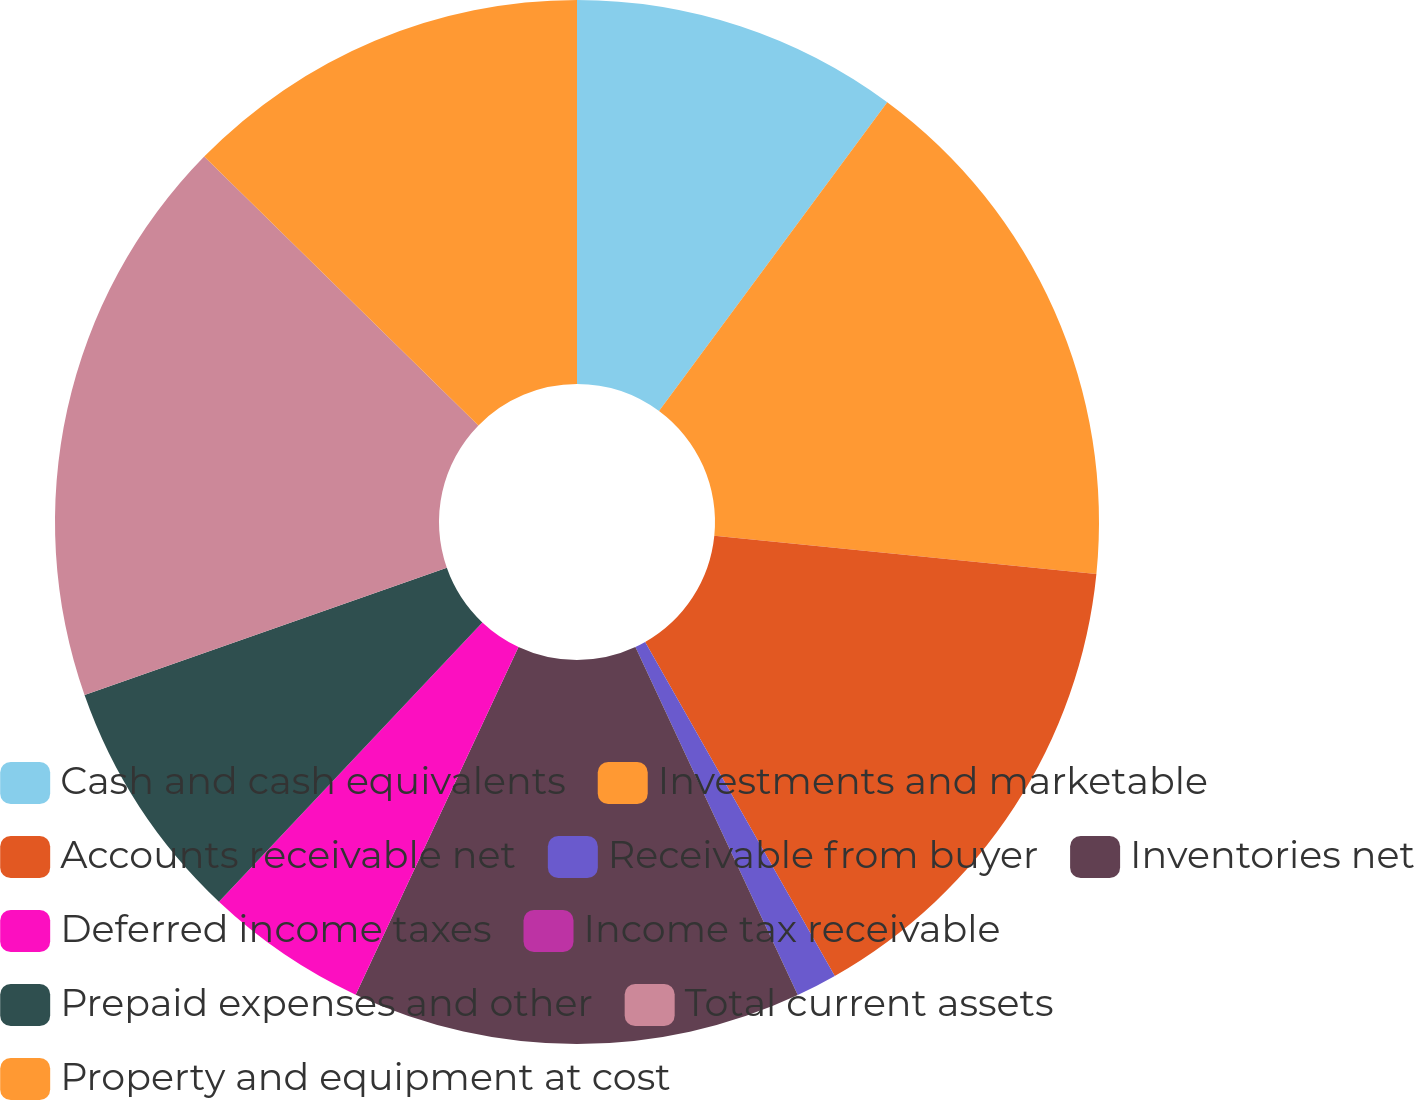Convert chart to OTSL. <chart><loc_0><loc_0><loc_500><loc_500><pie_chart><fcel>Cash and cash equivalents<fcel>Investments and marketable<fcel>Accounts receivable net<fcel>Receivable from buyer<fcel>Inventories net<fcel>Deferred income taxes<fcel>Income tax receivable<fcel>Prepaid expenses and other<fcel>Total current assets<fcel>Property and equipment at cost<nl><fcel>10.13%<fcel>16.46%<fcel>15.19%<fcel>1.27%<fcel>13.92%<fcel>5.06%<fcel>0.0%<fcel>7.59%<fcel>17.72%<fcel>12.66%<nl></chart> 